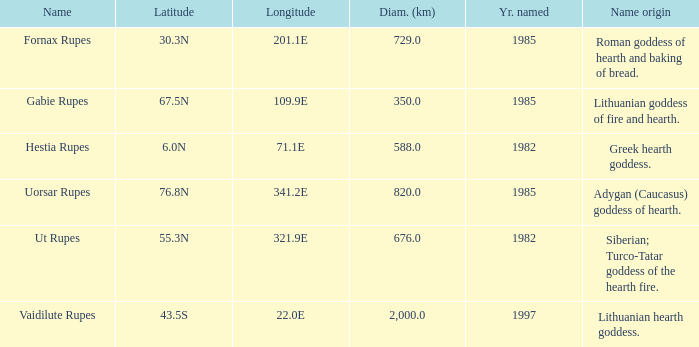Help me parse the entirety of this table. {'header': ['Name', 'Latitude', 'Longitude', 'Diam. (km)', 'Yr. named', 'Name origin'], 'rows': [['Fornax Rupes', '30.3N', '201.1E', '729.0', '1985', 'Roman goddess of hearth and baking of bread.'], ['Gabie Rupes', '67.5N', '109.9E', '350.0', '1985', 'Lithuanian goddess of fire and hearth.'], ['Hestia Rupes', '6.0N', '71.1E', '588.0', '1982', 'Greek hearth goddess.'], ['Uorsar Rupes', '76.8N', '341.2E', '820.0', '1985', 'Adygan (Caucasus) goddess of hearth.'], ['Ut Rupes', '55.3N', '321.9E', '676.0', '1982', 'Siberian; Turco-Tatar goddess of the hearth fire.'], ['Vaidilute Rupes', '43.5S', '22.0E', '2,000.0', '1997', 'Lithuanian hearth goddess.']]} What is the latitude of vaidilute rupes? 43.5S. 